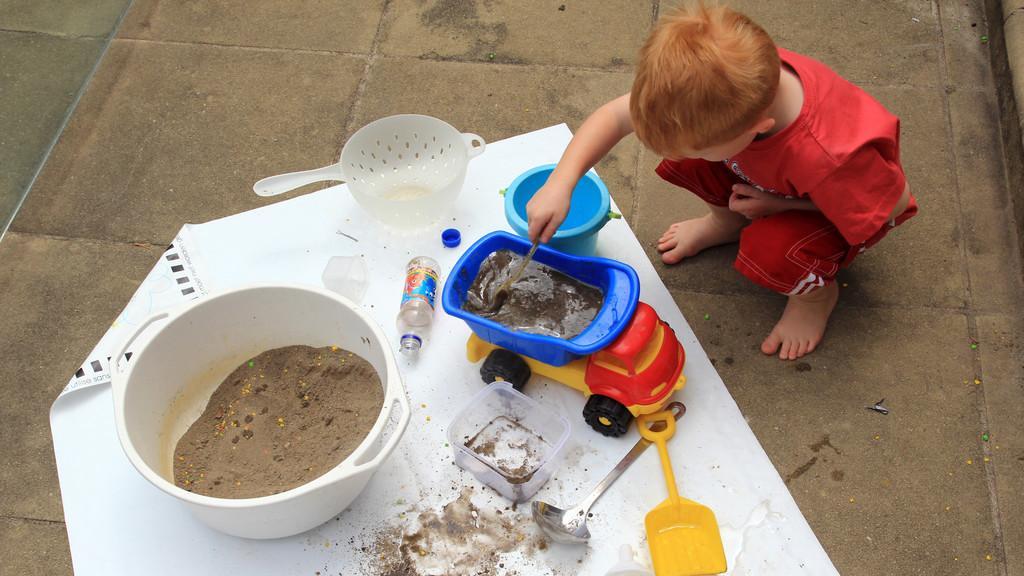In one or two sentences, can you explain what this image depicts? In this image there is a person and at the bottom there is a bowl, bottle, toy, spoon and sheet. 